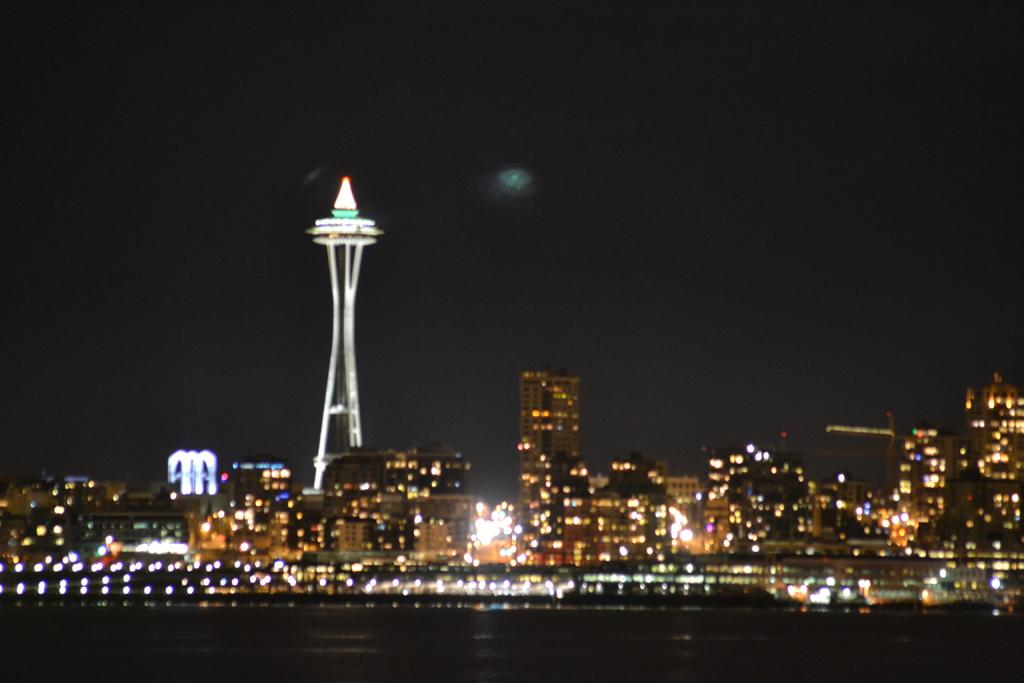What time of day was the image taken? The image was taken at night. What can be seen in the background of the image? There are buildings in the background of the image. How are the buildings illuminated in the image? The buildings have many lights. What part of the natural environment is visible in the image? The sky is visible in the image. What type of science experiment is being conducted in the image? There is no science experiment present in the image; it features buildings at night with many lights. What type of vacation destination is depicted in the image? The image does not depict a vacation destination; it shows buildings at night with many lights. 